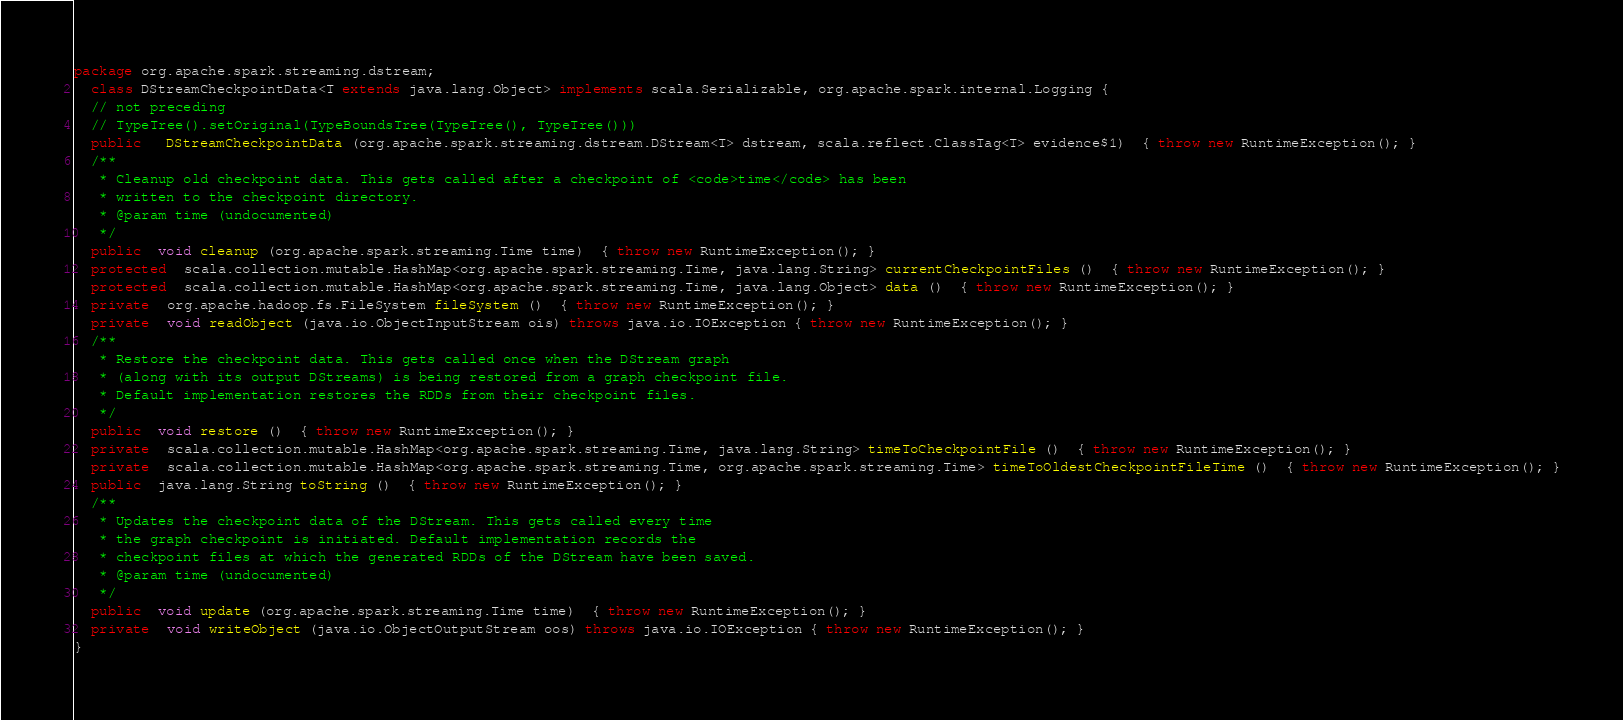Convert code to text. <code><loc_0><loc_0><loc_500><loc_500><_Java_>package org.apache.spark.streaming.dstream;
  class DStreamCheckpointData<T extends java.lang.Object> implements scala.Serializable, org.apache.spark.internal.Logging {
  // not preceding
  // TypeTree().setOriginal(TypeBoundsTree(TypeTree(), TypeTree()))
  public   DStreamCheckpointData (org.apache.spark.streaming.dstream.DStream<T> dstream, scala.reflect.ClassTag<T> evidence$1)  { throw new RuntimeException(); }
  /**
   * Cleanup old checkpoint data. This gets called after a checkpoint of <code>time</code> has been
   * written to the checkpoint directory.
   * @param time (undocumented)
   */
  public  void cleanup (org.apache.spark.streaming.Time time)  { throw new RuntimeException(); }
  protected  scala.collection.mutable.HashMap<org.apache.spark.streaming.Time, java.lang.String> currentCheckpointFiles ()  { throw new RuntimeException(); }
  protected  scala.collection.mutable.HashMap<org.apache.spark.streaming.Time, java.lang.Object> data ()  { throw new RuntimeException(); }
  private  org.apache.hadoop.fs.FileSystem fileSystem ()  { throw new RuntimeException(); }
  private  void readObject (java.io.ObjectInputStream ois) throws java.io.IOException { throw new RuntimeException(); }
  /**
   * Restore the checkpoint data. This gets called once when the DStream graph
   * (along with its output DStreams) is being restored from a graph checkpoint file.
   * Default implementation restores the RDDs from their checkpoint files.
   */
  public  void restore ()  { throw new RuntimeException(); }
  private  scala.collection.mutable.HashMap<org.apache.spark.streaming.Time, java.lang.String> timeToCheckpointFile ()  { throw new RuntimeException(); }
  private  scala.collection.mutable.HashMap<org.apache.spark.streaming.Time, org.apache.spark.streaming.Time> timeToOldestCheckpointFileTime ()  { throw new RuntimeException(); }
  public  java.lang.String toString ()  { throw new RuntimeException(); }
  /**
   * Updates the checkpoint data of the DStream. This gets called every time
   * the graph checkpoint is initiated. Default implementation records the
   * checkpoint files at which the generated RDDs of the DStream have been saved.
   * @param time (undocumented)
   */
  public  void update (org.apache.spark.streaming.Time time)  { throw new RuntimeException(); }
  private  void writeObject (java.io.ObjectOutputStream oos) throws java.io.IOException { throw new RuntimeException(); }
}
</code> 